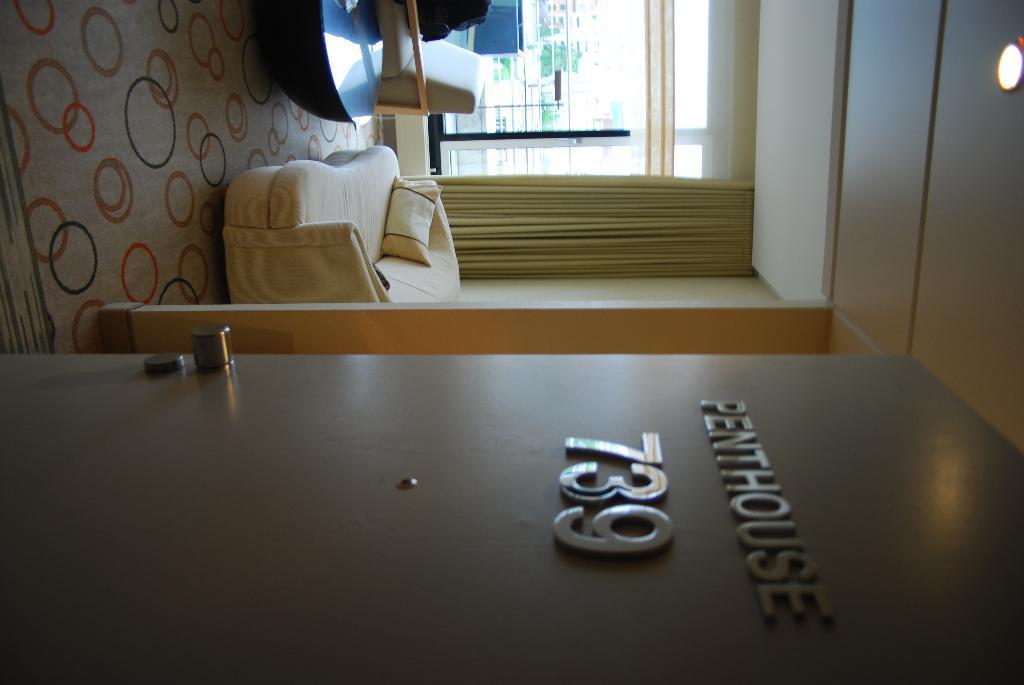Describe this image in one or two sentences. In this image i can see a couch, a pillow in yellow color and a board, a glass wall, yellow color curtain and a table. 